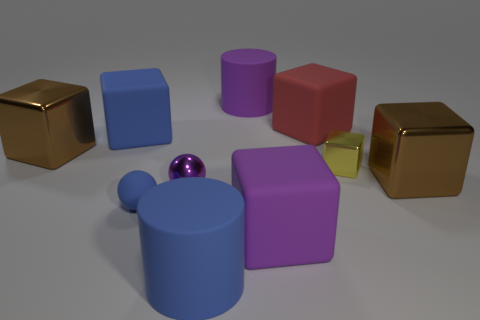What is the large block that is in front of the yellow metal cube and left of the tiny yellow thing made of?
Keep it short and to the point. Rubber. Are there fewer big blue matte things that are right of the blue ball than large metal things that are behind the tiny purple shiny ball?
Give a very brief answer. Yes. There is a blue ball that is made of the same material as the big purple cylinder; what is its size?
Ensure brevity in your answer.  Small. Is there anything else of the same color as the tiny cube?
Offer a terse response. No. Does the big blue cylinder have the same material as the brown thing that is on the right side of the small purple thing?
Ensure brevity in your answer.  No. There is a big blue thing that is the same shape as the red thing; what is its material?
Give a very brief answer. Rubber. Is the cylinder that is in front of the tiny shiny sphere made of the same material as the ball on the left side of the metallic sphere?
Provide a short and direct response. Yes. What color is the tiny object to the right of the purple matte thing that is behind the purple thing that is right of the purple matte cylinder?
Keep it short and to the point. Yellow. How many other things are there of the same shape as the red object?
Offer a very short reply. 5. What number of things are either big purple rubber cylinders or large matte objects that are right of the small blue matte sphere?
Make the answer very short. 4. 